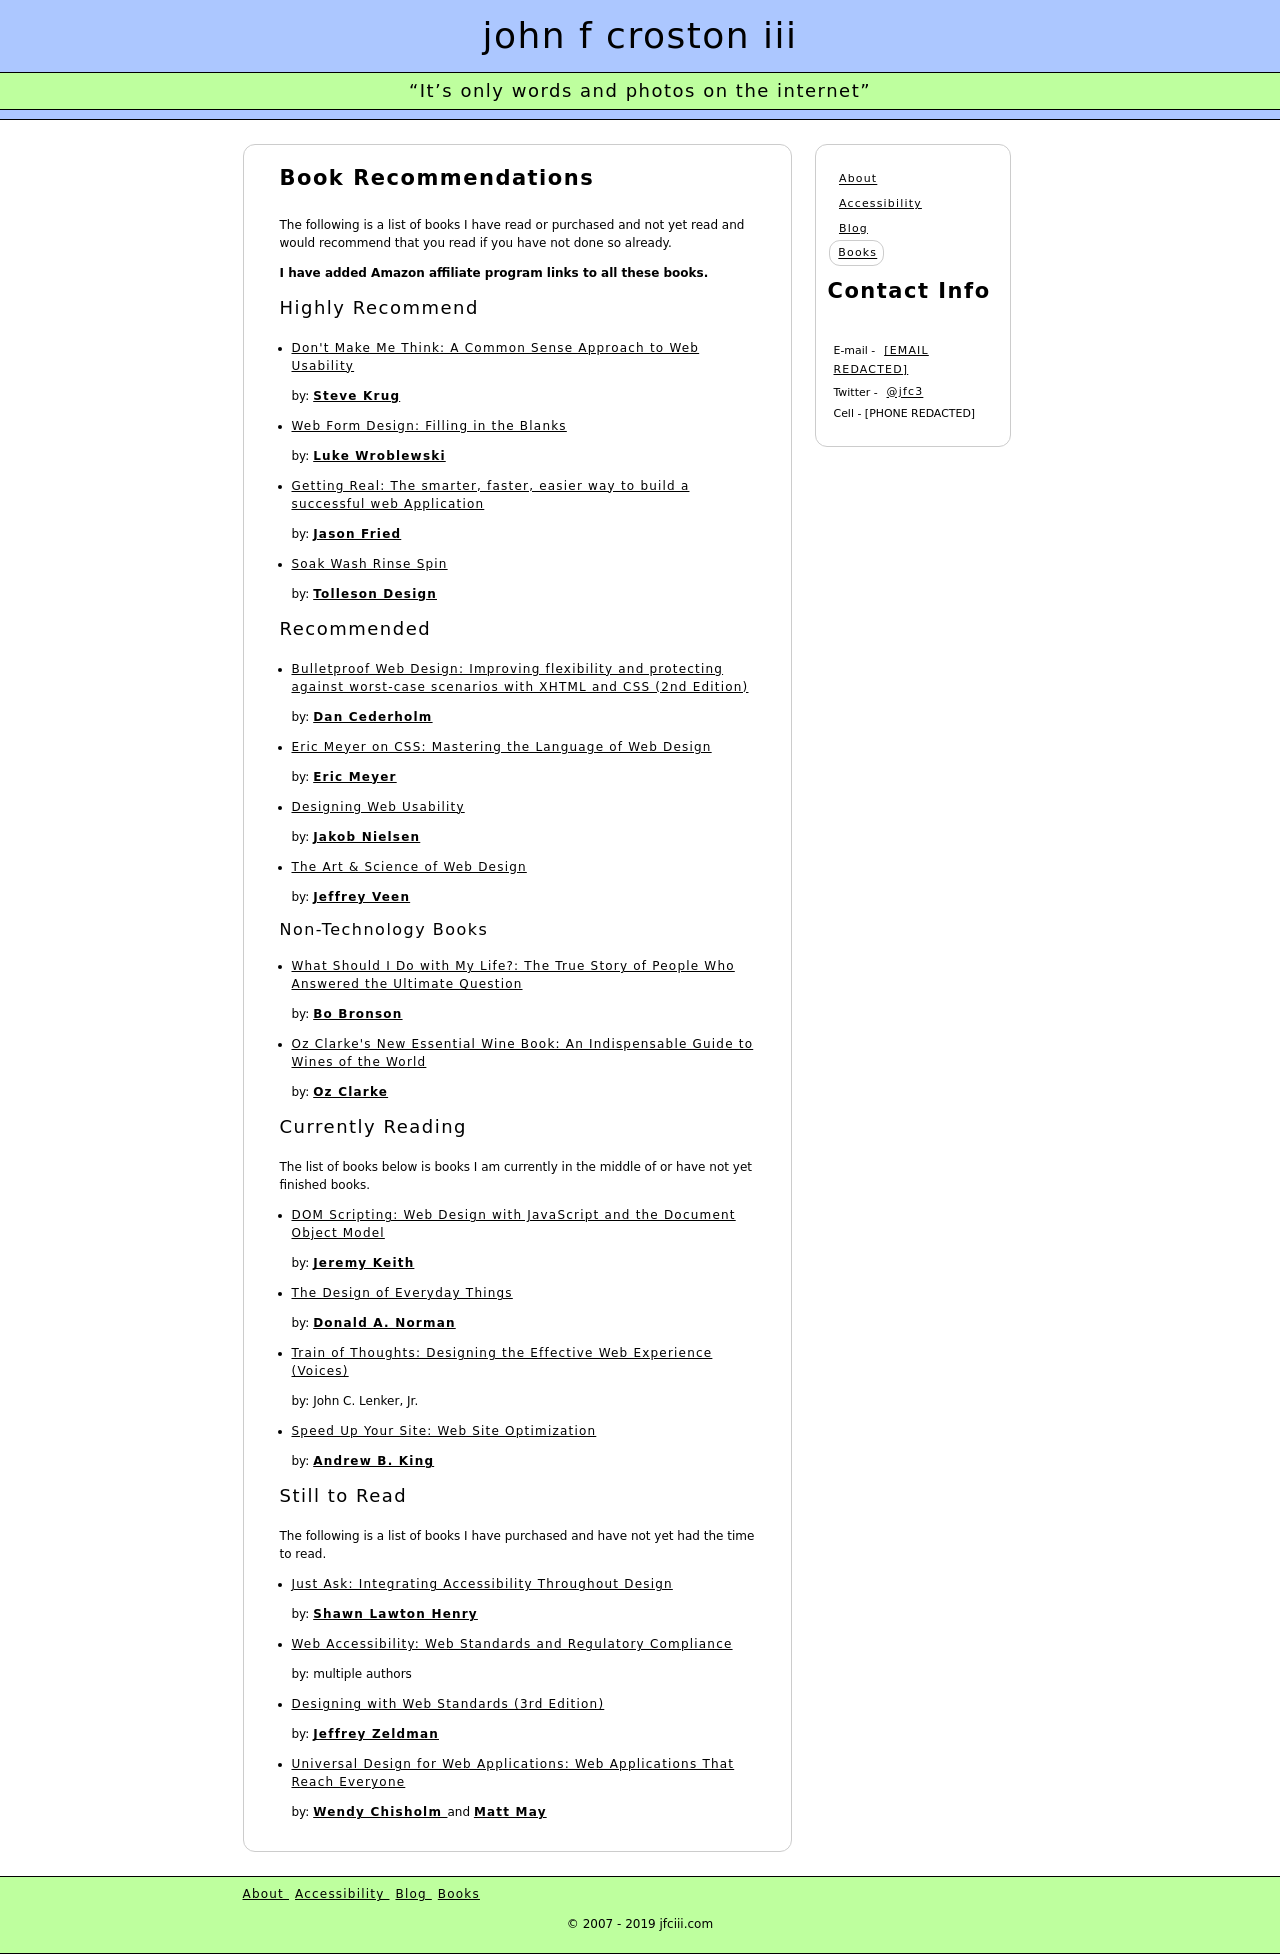What are the main categories listed on this webpage? The main categories listed on the webpage are: Highly Recommend, Recommended, Non-Technology Books, Currently Reading, and Still to Read. Each category contains a list of books that the website author suggests. 